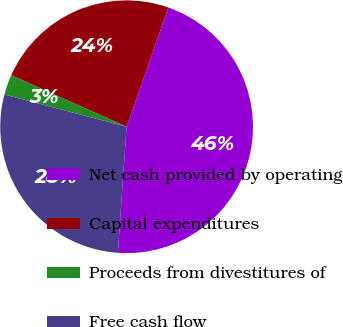Convert chart. <chart><loc_0><loc_0><loc_500><loc_500><pie_chart><fcel>Net cash provided by operating<fcel>Capital expenditures<fcel>Proceeds from divestitures of<fcel>Free cash flow<nl><fcel>45.75%<fcel>23.68%<fcel>2.57%<fcel>28.0%<nl></chart> 